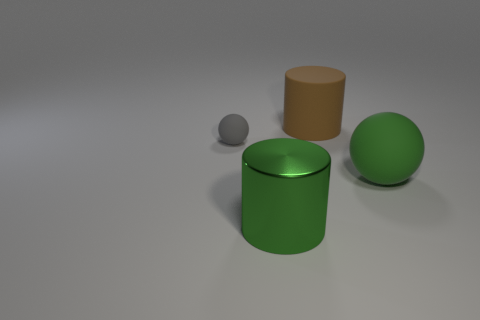Are there any shadows in the image that can tell us about the light source? Yes, the objects cast diffuse shadows that spread out softly from the base of each object. This indicates a broad, non-directional light source, likely positioned above the scene, creating soft-edged shadows and mild contrast. 